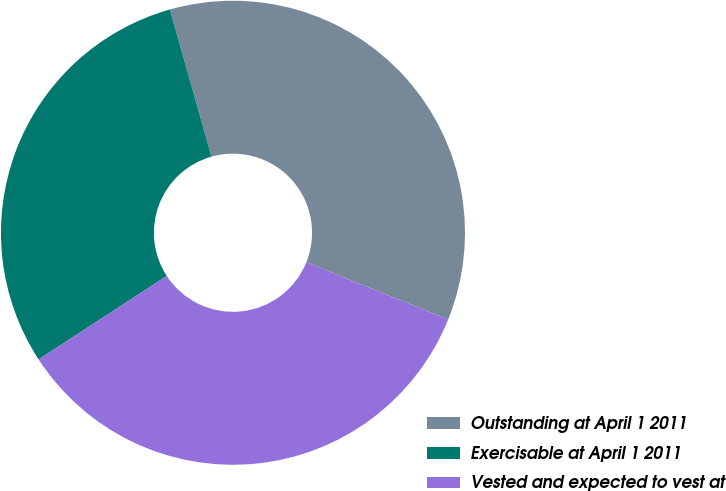<chart> <loc_0><loc_0><loc_500><loc_500><pie_chart><fcel>Outstanding at April 1 2011<fcel>Exercisable at April 1 2011<fcel>Vested and expected to vest at<nl><fcel>35.48%<fcel>29.81%<fcel>34.71%<nl></chart> 